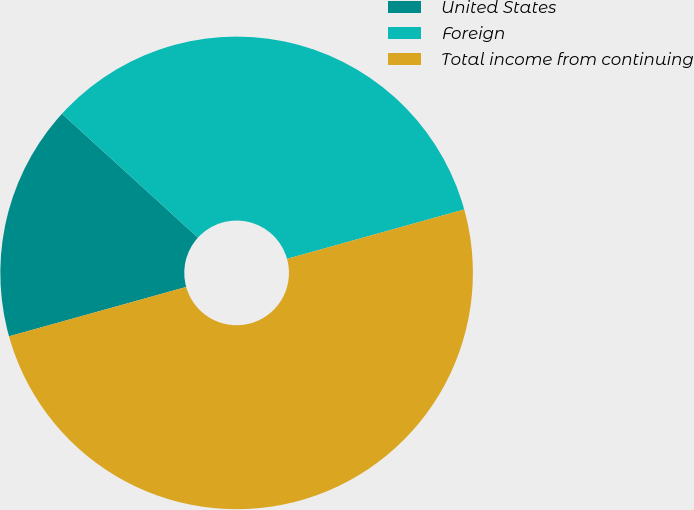Convert chart to OTSL. <chart><loc_0><loc_0><loc_500><loc_500><pie_chart><fcel>United States<fcel>Foreign<fcel>Total income from continuing<nl><fcel>16.09%<fcel>33.91%<fcel>50.0%<nl></chart> 